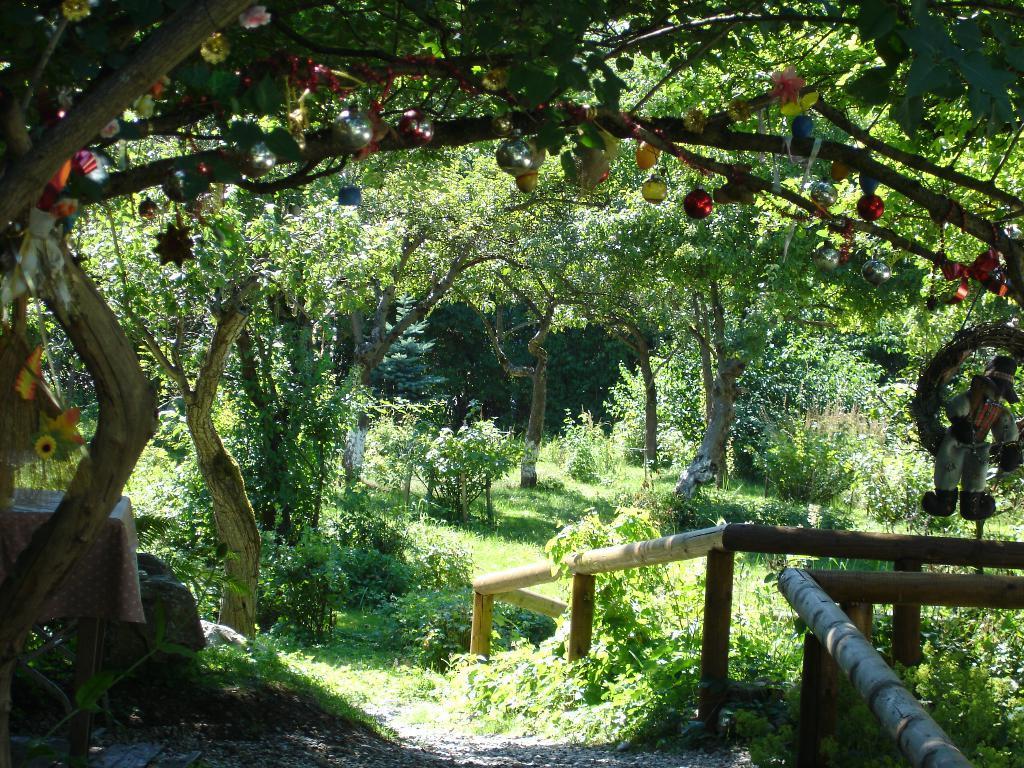Can you describe this image briefly? In the image to the left side there is a tree with decorative items like balls, flowers and some other decorative items hanging to it. And to the right side of the image there is a doll hanging to the wall. And to the right bottom of the image there is a railing. And in the background there are many trees. On the ground there is grass. 